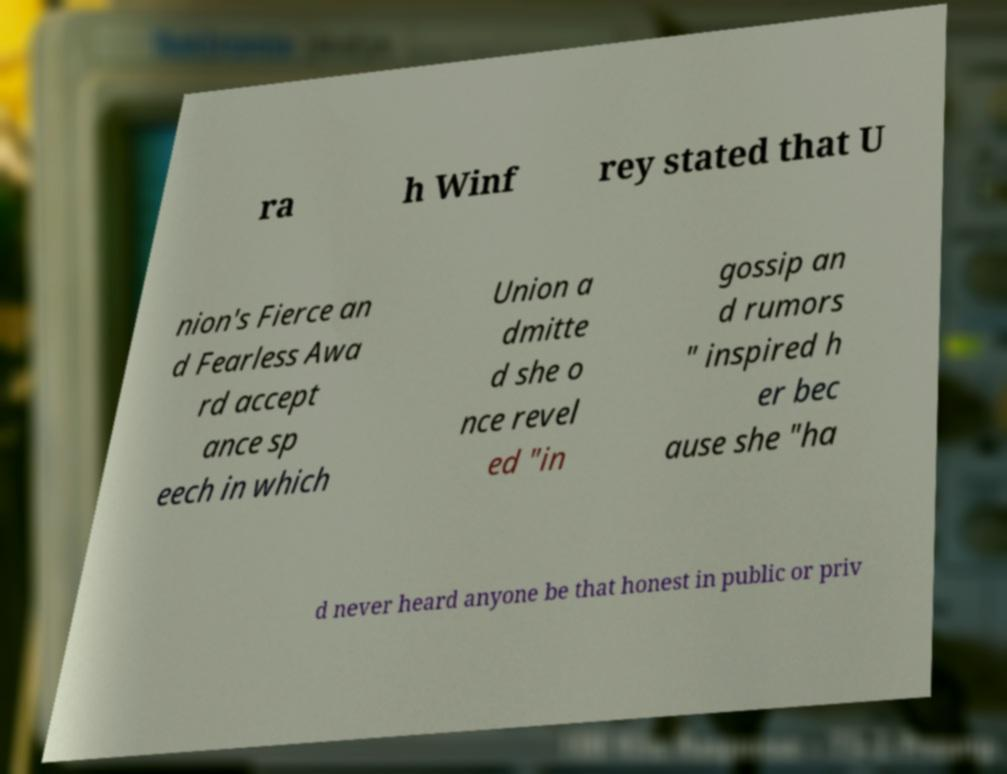For documentation purposes, I need the text within this image transcribed. Could you provide that? ra h Winf rey stated that U nion's Fierce an d Fearless Awa rd accept ance sp eech in which Union a dmitte d she o nce revel ed "in gossip an d rumors " inspired h er bec ause she "ha d never heard anyone be that honest in public or priv 